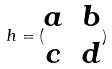<formula> <loc_0><loc_0><loc_500><loc_500>h = ( \begin{matrix} a & b \\ c & d \end{matrix} )</formula> 